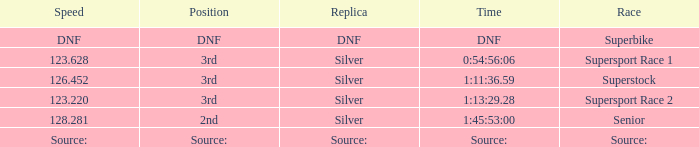Give me the full table as a dictionary. {'header': ['Speed', 'Position', 'Replica', 'Time', 'Race'], 'rows': [['DNF', 'DNF', 'DNF', 'DNF', 'Superbike'], ['123.628', '3rd', 'Silver', '0:54:56:06', 'Supersport Race 1'], ['126.452', '3rd', 'Silver', '1:11:36.59', 'Superstock'], ['123.220', '3rd', 'Silver', '1:13:29.28', 'Supersport Race 2'], ['128.281', '2nd', 'Silver', '1:45:53:00', 'Senior'], ['Source:', 'Source:', 'Source:', 'Source:', 'Source:']]} Which race has a position of 3rd and a speed of 123.628? Supersport Race 1. 